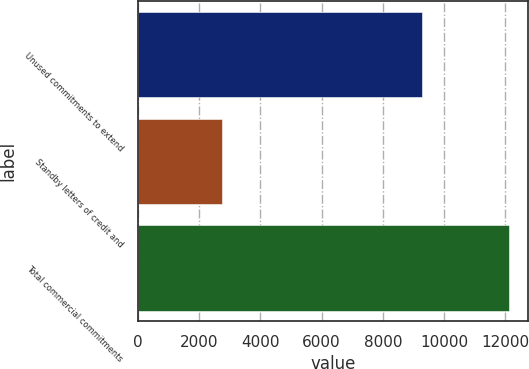Convert chart to OTSL. <chart><loc_0><loc_0><loc_500><loc_500><bar_chart><fcel>Unused commitments to extend<fcel>Standby letters of credit and<fcel>Total commercial commitments<nl><fcel>9287<fcel>2757<fcel>12119<nl></chart> 